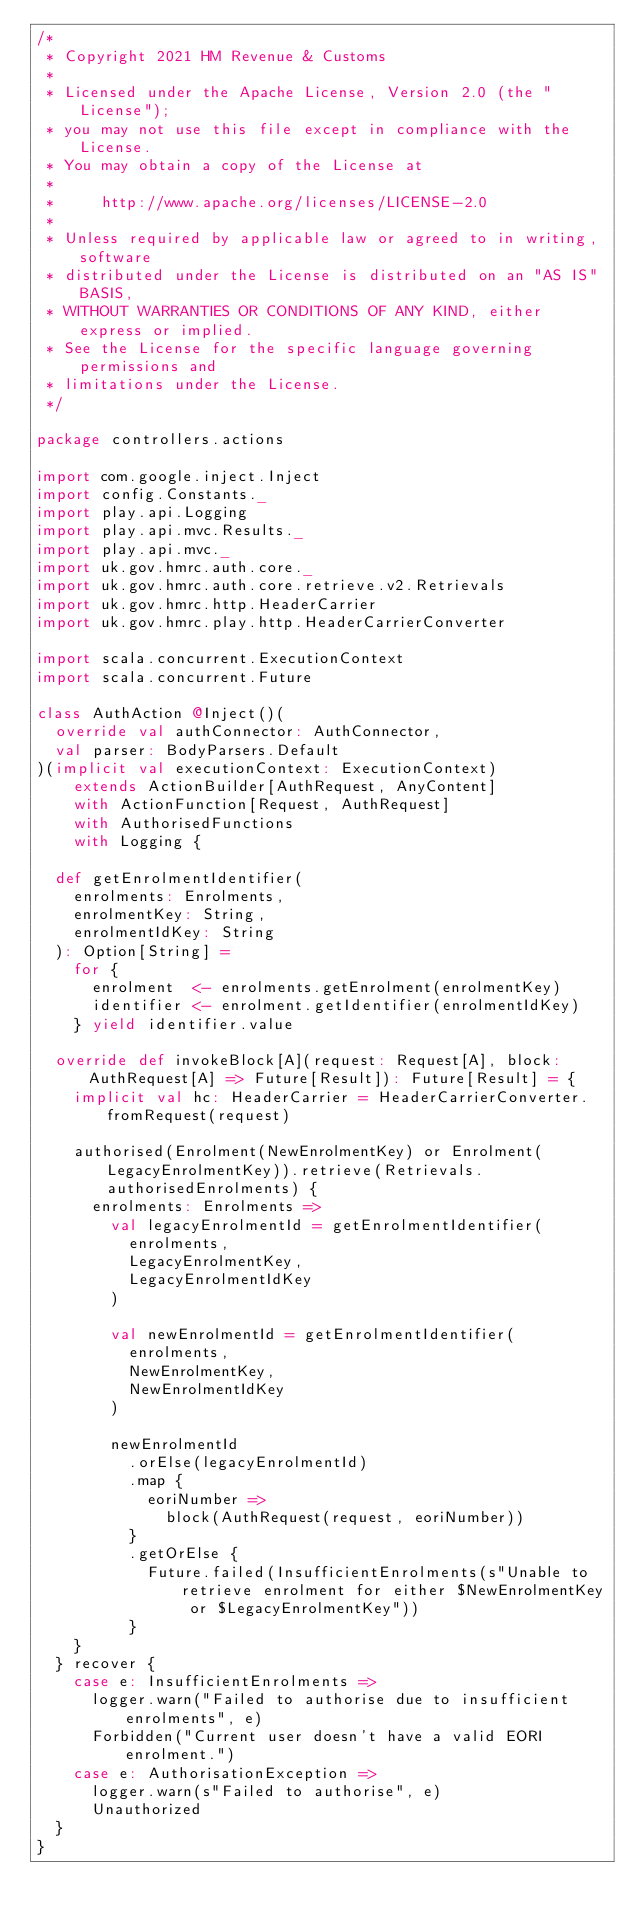Convert code to text. <code><loc_0><loc_0><loc_500><loc_500><_Scala_>/*
 * Copyright 2021 HM Revenue & Customs
 *
 * Licensed under the Apache License, Version 2.0 (the "License");
 * you may not use this file except in compliance with the License.
 * You may obtain a copy of the License at
 *
 *     http://www.apache.org/licenses/LICENSE-2.0
 *
 * Unless required by applicable law or agreed to in writing, software
 * distributed under the License is distributed on an "AS IS" BASIS,
 * WITHOUT WARRANTIES OR CONDITIONS OF ANY KIND, either express or implied.
 * See the License for the specific language governing permissions and
 * limitations under the License.
 */

package controllers.actions

import com.google.inject.Inject
import config.Constants._
import play.api.Logging
import play.api.mvc.Results._
import play.api.mvc._
import uk.gov.hmrc.auth.core._
import uk.gov.hmrc.auth.core.retrieve.v2.Retrievals
import uk.gov.hmrc.http.HeaderCarrier
import uk.gov.hmrc.play.http.HeaderCarrierConverter

import scala.concurrent.ExecutionContext
import scala.concurrent.Future

class AuthAction @Inject()(
  override val authConnector: AuthConnector,
  val parser: BodyParsers.Default
)(implicit val executionContext: ExecutionContext)
    extends ActionBuilder[AuthRequest, AnyContent]
    with ActionFunction[Request, AuthRequest]
    with AuthorisedFunctions
    with Logging {

  def getEnrolmentIdentifier(
    enrolments: Enrolments,
    enrolmentKey: String,
    enrolmentIdKey: String
  ): Option[String] =
    for {
      enrolment  <- enrolments.getEnrolment(enrolmentKey)
      identifier <- enrolment.getIdentifier(enrolmentIdKey)
    } yield identifier.value

  override def invokeBlock[A](request: Request[A], block: AuthRequest[A] => Future[Result]): Future[Result] = {
    implicit val hc: HeaderCarrier = HeaderCarrierConverter.fromRequest(request)

    authorised(Enrolment(NewEnrolmentKey) or Enrolment(LegacyEnrolmentKey)).retrieve(Retrievals.authorisedEnrolments) {
      enrolments: Enrolments =>
        val legacyEnrolmentId = getEnrolmentIdentifier(
          enrolments,
          LegacyEnrolmentKey,
          LegacyEnrolmentIdKey
        )

        val newEnrolmentId = getEnrolmentIdentifier(
          enrolments,
          NewEnrolmentKey,
          NewEnrolmentIdKey
        )

        newEnrolmentId
          .orElse(legacyEnrolmentId)
          .map {
            eoriNumber =>
              block(AuthRequest(request, eoriNumber))
          }
          .getOrElse {
            Future.failed(InsufficientEnrolments(s"Unable to retrieve enrolment for either $NewEnrolmentKey or $LegacyEnrolmentKey"))
          }
    }
  } recover {
    case e: InsufficientEnrolments =>
      logger.warn("Failed to authorise due to insufficient enrolments", e)
      Forbidden("Current user doesn't have a valid EORI enrolment.")
    case e: AuthorisationException =>
      logger.warn(s"Failed to authorise", e)
      Unauthorized
  }
}
</code> 